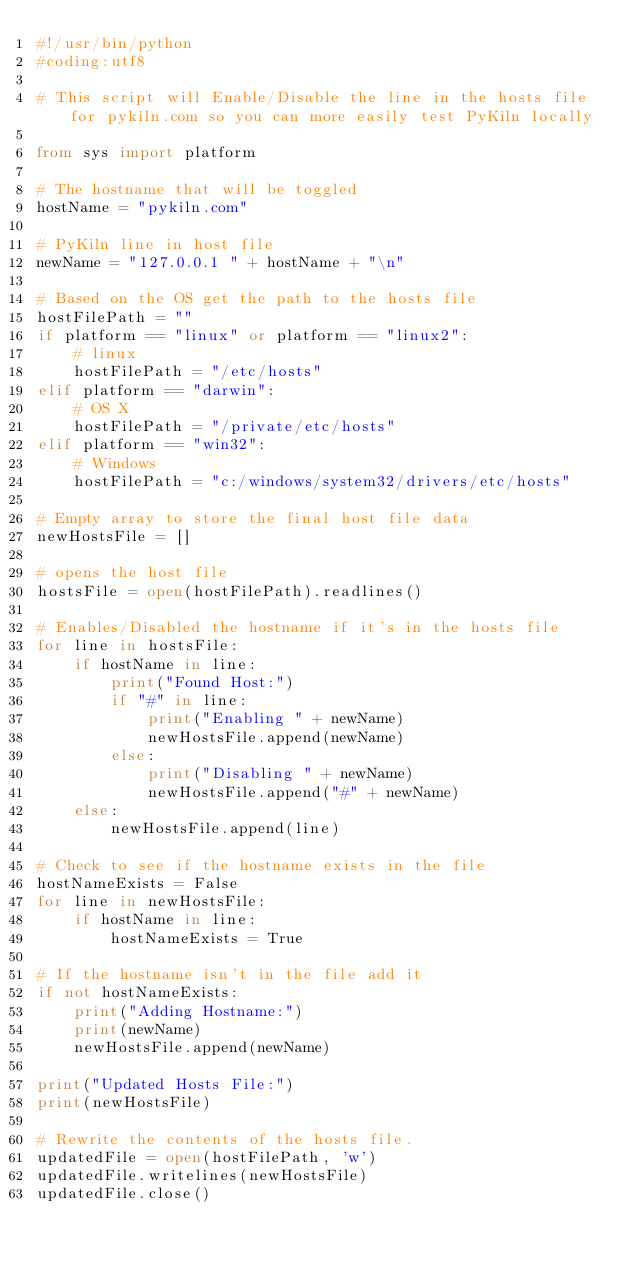Convert code to text. <code><loc_0><loc_0><loc_500><loc_500><_Python_>#!/usr/bin/python
#coding:utf8

# This script will Enable/Disable the line in the hosts file for pykiln.com so you can more easily test PyKiln locally

from sys import platform

# The hostname that will be toggled
hostName = "pykiln.com"

# PyKiln line in host file
newName = "127.0.0.1 " + hostName + "\n"

# Based on the OS get the path to the hosts file
hostFilePath = ""
if platform == "linux" or platform == "linux2":
    # linux
    hostFilePath = "/etc/hosts"
elif platform == "darwin":
    # OS X
    hostFilePath = "/private/etc/hosts"
elif platform == "win32":
    # Windows
    hostFilePath = "c:/windows/system32/drivers/etc/hosts"

# Empty array to store the final host file data
newHostsFile = [] 

# opens the host file
hostsFile = open(hostFilePath).readlines()

# Enables/Disabled the hostname if it's in the hosts file
for line in hostsFile:
    if hostName in line:
        print("Found Host:")
        if "#" in line:
            print("Enabling " + newName)
            newHostsFile.append(newName)
        else:
            print("Disabling " + newName)
            newHostsFile.append("#" + newName)  
    else:
        newHostsFile.append(line)

# Check to see if the hostname exists in the file
hostNameExists = False
for line in newHostsFile:
    if hostName in line:
        hostNameExists = True

# If the hostname isn't in the file add it
if not hostNameExists:
    print("Adding Hostname:")
    print(newName)
    newHostsFile.append(newName)

print("Updated Hosts File:")
print(newHostsFile)

# Rewrite the contents of the hosts file.
updatedFile = open(hostFilePath, 'w')
updatedFile.writelines(newHostsFile)
updatedFile.close()
</code> 